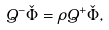<formula> <loc_0><loc_0><loc_500><loc_500>Q ^ { - } \check { \Phi } = \rho Q ^ { + } \check { \Phi } ,</formula> 